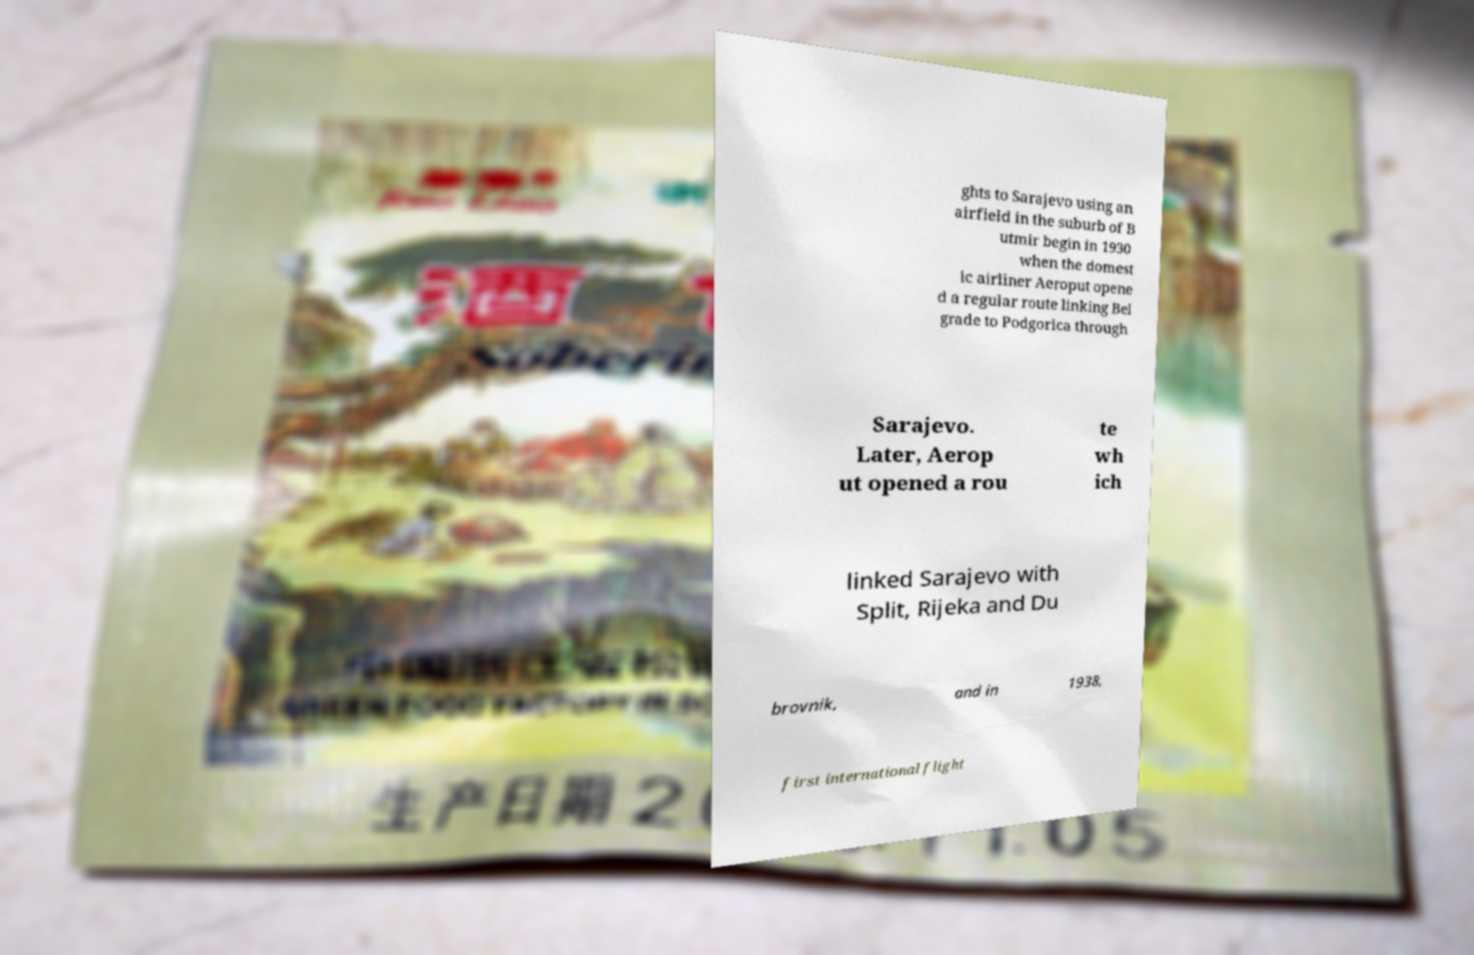For documentation purposes, I need the text within this image transcribed. Could you provide that? ghts to Sarajevo using an airfield in the suburb of B utmir begin in 1930 when the domest ic airliner Aeroput opene d a regular route linking Bel grade to Podgorica through Sarajevo. Later, Aerop ut opened a rou te wh ich linked Sarajevo with Split, Rijeka and Du brovnik, and in 1938, first international flight 